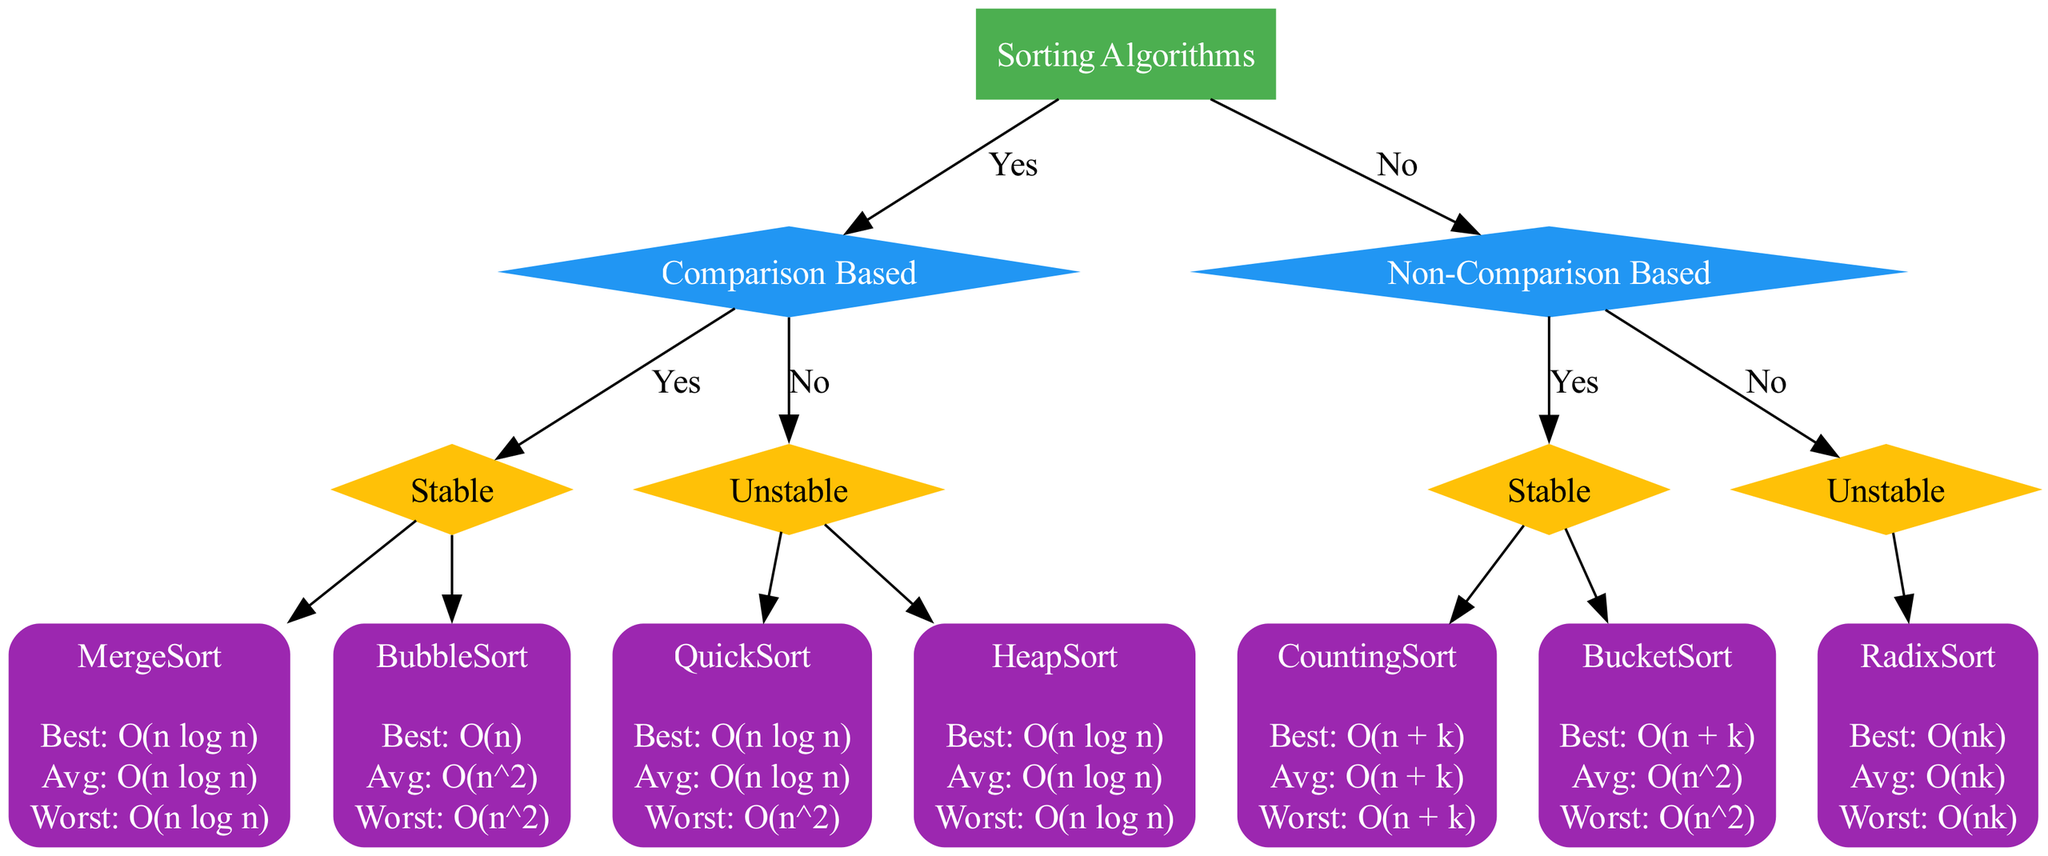What is the best time complexity of MergeSort? The diagram specifically lists the time complexities for MergeSort under the "Stable" node in the "Comparison Based" category. The best time complexity is explicitly labeled as "O(n log n)."
Answer: O(n log n) How many stable sorting algorithms are present in the diagram? Examining the diagram, one can count the stable sorting algorithms listed under both "Comparison Based" and "Non-Comparison Based." There are four stable sorting algorithms: MergeSort, BubbleSort, CountingSort, and BucketSort.
Answer: 4 Which sorting algorithm has the worst time complexity of O(n^2)? By inspecting the diagram, BubbleSort and BucketSort are identified as having a worst time complexity of O(n^2). I will narrow it down further since we want only one algorithm: BubbleSort is the first encountered in the stable category.
Answer: BubbleSort What is the relationship between QuickSort and stability? QuickSort is placed under the "Unstable" category within the "Comparison Based" section of the diagram. Therefore, it is specifically categorized as an unstable sorting algorithm.
Answer: Unstable Which has the best average time complexity: CountingSort or BubbleSort? Reviewing the average time complexities listed in the diagram, CountingSort has an average time complexity of O(n + k), whereas BubbleSort has O(n^2). Comparing these two, O(n + k) is better than O(n^2).
Answer: CountingSort What is the worst-case time complexity of HeapSort? Let's look under the "Unstable" node in the "Comparison Based" category, where HeapSort is found with a worst-case time complexity of O(n log n), as denoted in the diagram.
Answer: O(n log n) In which category is RadixSort classified? RadixSort appears under the "Unstable" node in the "Non-Comparison Based" section, indicating its classification within that specific category.
Answer: Unstable What is the average time complexity of BucketSort? The average time complexity of BucketSort is listed directly under its corresponding node in the diagram as O(n^2), allowing easy reference to this specific detail.
Answer: O(n^2) 